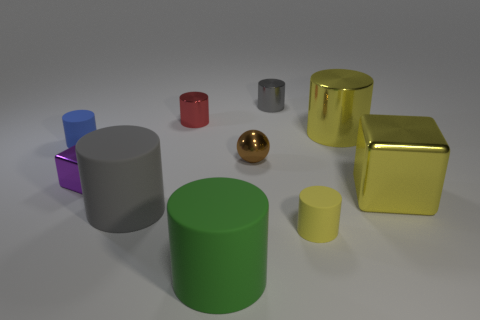What is the shape of the small red object that is the same material as the tiny brown thing?
Offer a terse response. Cylinder. Does the gray cylinder that is behind the big metallic block have the same material as the small purple object?
Make the answer very short. Yes. What number of other objects are there of the same material as the tiny brown sphere?
Ensure brevity in your answer.  5. How many objects are either yellow metal things on the left side of the yellow metallic cube or tiny shiny things behind the small block?
Keep it short and to the point. 4. There is a large matte thing to the left of the tiny red thing; does it have the same shape as the gray thing that is on the right side of the large gray rubber thing?
Ensure brevity in your answer.  Yes. There is a brown metal thing that is the same size as the red thing; what is its shape?
Offer a terse response. Sphere. How many metallic objects are either blue objects or small objects?
Offer a very short reply. 4. Do the yellow cube that is to the right of the big gray object and the large yellow cylinder to the right of the red cylinder have the same material?
Keep it short and to the point. Yes. There is a large block that is made of the same material as the ball; what is its color?
Keep it short and to the point. Yellow. Is the number of tiny red cylinders left of the big yellow cube greater than the number of large green rubber things that are on the left side of the purple shiny object?
Your response must be concise. Yes. 